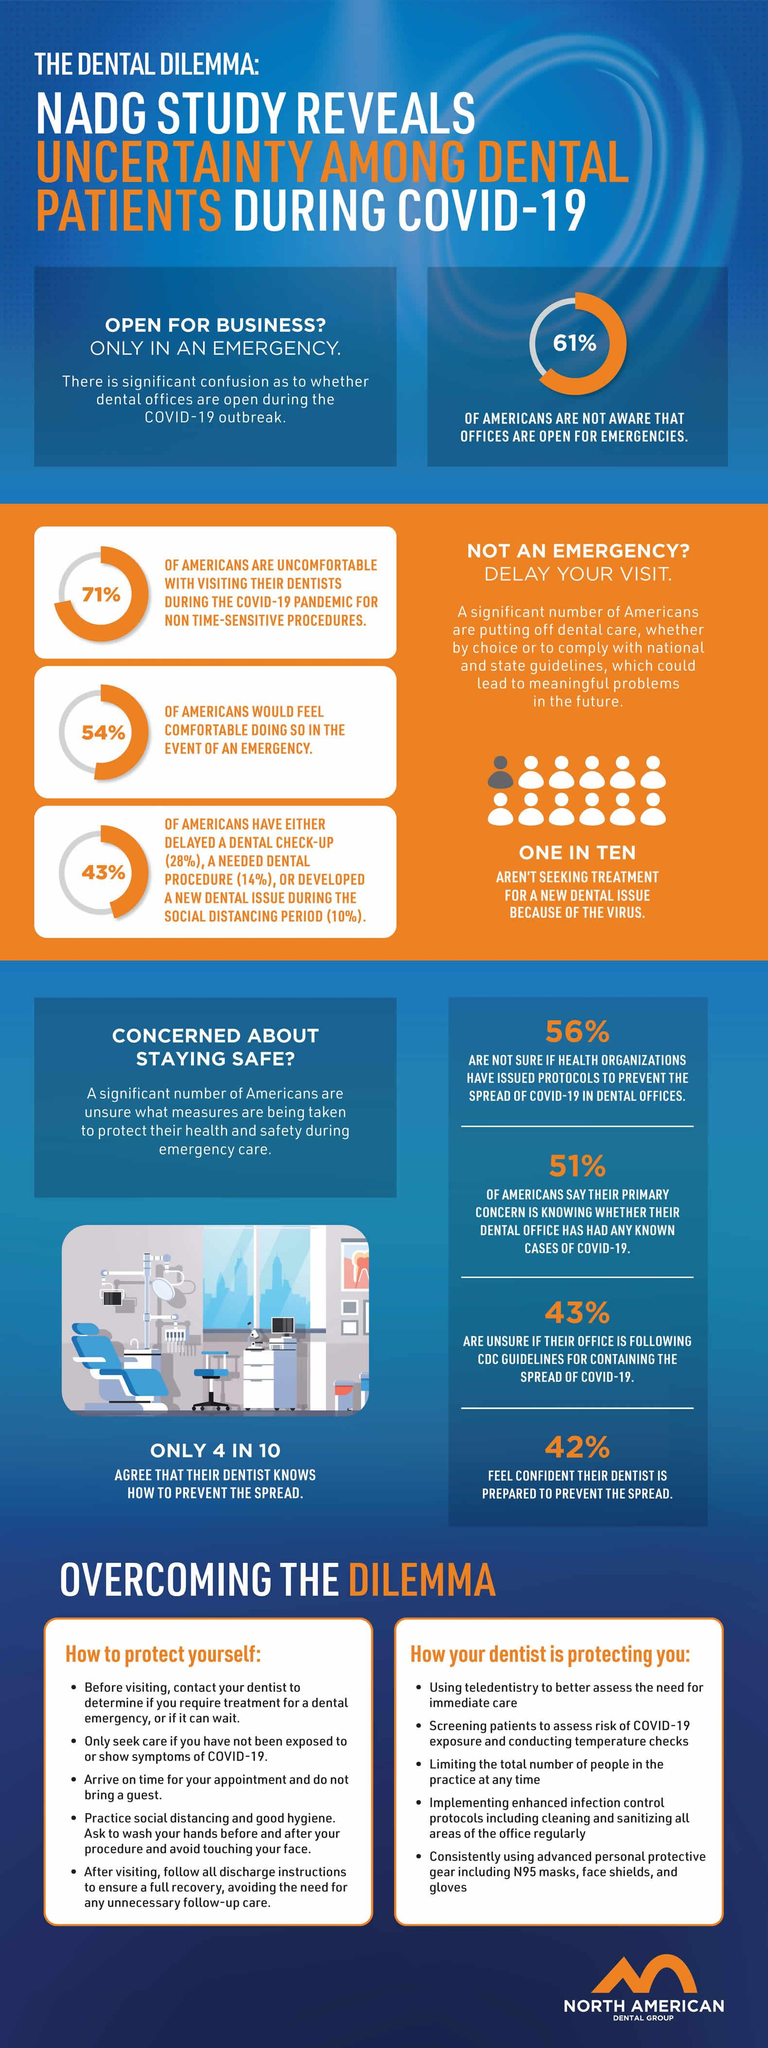Outline some significant characteristics in this image. A recent survey found that only 39% of Americans are aware that dental offices are open for emergencies during COVID-19. According to a recent survey, 57% of Americans believe that their dental office is adhering to the guidelines set by the CDC to prevent the spread of COVID-19. According to a recent survey, a significant portion of Americans, 58%, do not feel confident that their dentist is prepared to prevent the spread of COVID-19. 